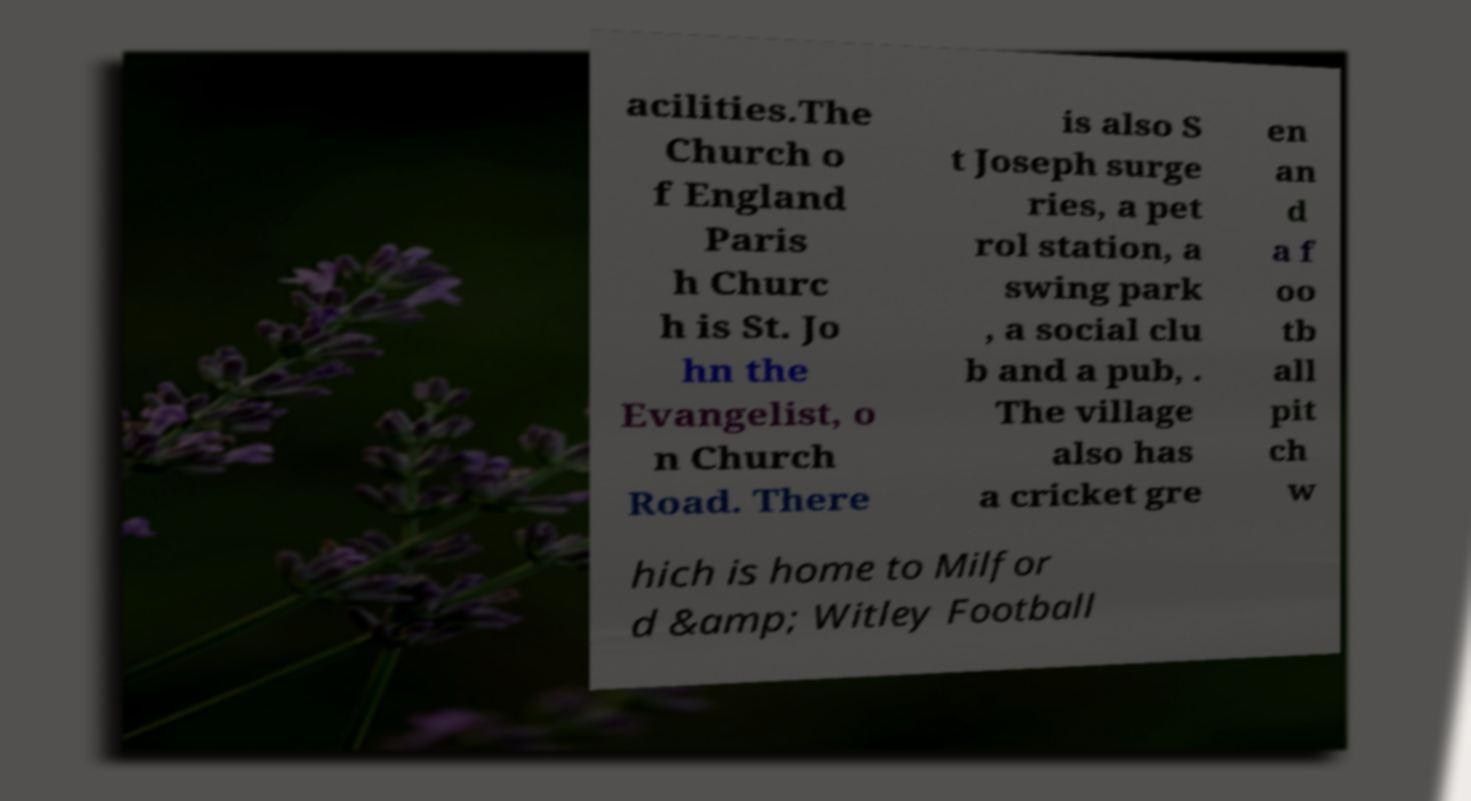Please read and relay the text visible in this image. What does it say? acilities.The Church o f England Paris h Churc h is St. Jo hn the Evangelist, o n Church Road. There is also S t Joseph surge ries, a pet rol station, a swing park , a social clu b and a pub, . The village also has a cricket gre en an d a f oo tb all pit ch w hich is home to Milfor d &amp; Witley Football 